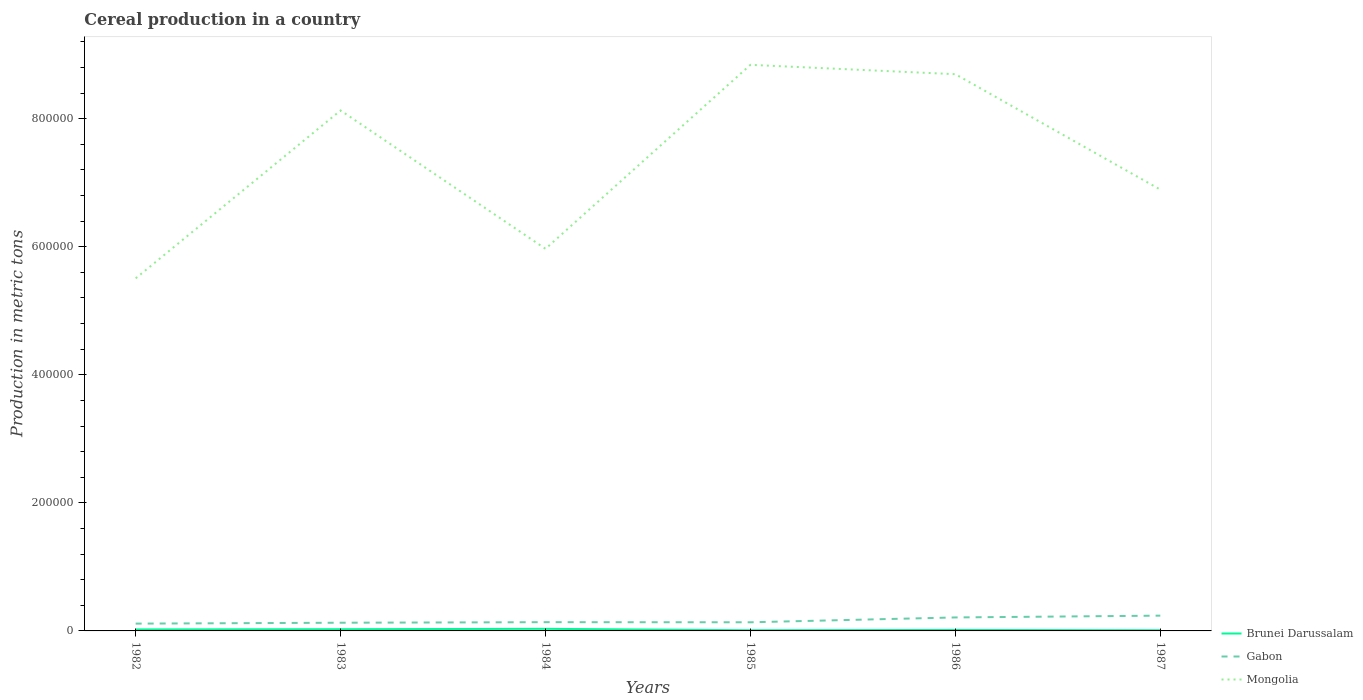How many different coloured lines are there?
Provide a short and direct response. 3. Across all years, what is the maximum total cereal production in Brunei Darussalam?
Offer a terse response. 1080. In which year was the total cereal production in Brunei Darussalam maximum?
Offer a very short reply. 1987. What is the total total cereal production in Brunei Darussalam in the graph?
Your response must be concise. -458. What is the difference between the highest and the second highest total cereal production in Gabon?
Offer a terse response. 1.25e+04. Is the total cereal production in Mongolia strictly greater than the total cereal production in Brunei Darussalam over the years?
Ensure brevity in your answer.  No. What is the difference between two consecutive major ticks on the Y-axis?
Give a very brief answer. 2.00e+05. Does the graph contain any zero values?
Provide a short and direct response. No. Where does the legend appear in the graph?
Ensure brevity in your answer.  Bottom right. What is the title of the graph?
Ensure brevity in your answer.  Cereal production in a country. Does "French Polynesia" appear as one of the legend labels in the graph?
Ensure brevity in your answer.  No. What is the label or title of the X-axis?
Keep it short and to the point. Years. What is the label or title of the Y-axis?
Your answer should be very brief. Production in metric tons. What is the Production in metric tons of Brunei Darussalam in 1982?
Offer a terse response. 2366. What is the Production in metric tons in Gabon in 1982?
Keep it short and to the point. 1.14e+04. What is the Production in metric tons in Mongolia in 1982?
Your answer should be very brief. 5.51e+05. What is the Production in metric tons in Brunei Darussalam in 1983?
Your response must be concise. 2676. What is the Production in metric tons in Gabon in 1983?
Your answer should be very brief. 1.28e+04. What is the Production in metric tons in Mongolia in 1983?
Your response must be concise. 8.13e+05. What is the Production in metric tons of Brunei Darussalam in 1984?
Provide a short and direct response. 3270. What is the Production in metric tons in Gabon in 1984?
Offer a terse response. 1.37e+04. What is the Production in metric tons in Mongolia in 1984?
Offer a very short reply. 5.97e+05. What is the Production in metric tons in Brunei Darussalam in 1985?
Provide a succinct answer. 1082. What is the Production in metric tons in Gabon in 1985?
Make the answer very short. 1.35e+04. What is the Production in metric tons of Mongolia in 1985?
Offer a very short reply. 8.84e+05. What is the Production in metric tons of Brunei Darussalam in 1986?
Ensure brevity in your answer.  1540. What is the Production in metric tons in Gabon in 1986?
Offer a terse response. 2.11e+04. What is the Production in metric tons in Mongolia in 1986?
Keep it short and to the point. 8.69e+05. What is the Production in metric tons of Brunei Darussalam in 1987?
Give a very brief answer. 1080. What is the Production in metric tons of Gabon in 1987?
Your answer should be very brief. 2.39e+04. What is the Production in metric tons in Mongolia in 1987?
Keep it short and to the point. 6.89e+05. Across all years, what is the maximum Production in metric tons of Brunei Darussalam?
Offer a terse response. 3270. Across all years, what is the maximum Production in metric tons of Gabon?
Your answer should be very brief. 2.39e+04. Across all years, what is the maximum Production in metric tons in Mongolia?
Provide a succinct answer. 8.84e+05. Across all years, what is the minimum Production in metric tons in Brunei Darussalam?
Your answer should be very brief. 1080. Across all years, what is the minimum Production in metric tons in Gabon?
Your answer should be compact. 1.14e+04. Across all years, what is the minimum Production in metric tons in Mongolia?
Provide a succinct answer. 5.51e+05. What is the total Production in metric tons in Brunei Darussalam in the graph?
Your answer should be very brief. 1.20e+04. What is the total Production in metric tons in Gabon in the graph?
Ensure brevity in your answer.  9.63e+04. What is the total Production in metric tons of Mongolia in the graph?
Provide a succinct answer. 4.40e+06. What is the difference between the Production in metric tons of Brunei Darussalam in 1982 and that in 1983?
Make the answer very short. -310. What is the difference between the Production in metric tons in Gabon in 1982 and that in 1983?
Keep it short and to the point. -1400. What is the difference between the Production in metric tons of Mongolia in 1982 and that in 1983?
Ensure brevity in your answer.  -2.62e+05. What is the difference between the Production in metric tons of Brunei Darussalam in 1982 and that in 1984?
Offer a terse response. -904. What is the difference between the Production in metric tons in Gabon in 1982 and that in 1984?
Offer a very short reply. -2262. What is the difference between the Production in metric tons of Mongolia in 1982 and that in 1984?
Provide a succinct answer. -4.61e+04. What is the difference between the Production in metric tons of Brunei Darussalam in 1982 and that in 1985?
Your answer should be very brief. 1284. What is the difference between the Production in metric tons of Gabon in 1982 and that in 1985?
Your answer should be very brief. -2100. What is the difference between the Production in metric tons of Mongolia in 1982 and that in 1985?
Make the answer very short. -3.33e+05. What is the difference between the Production in metric tons of Brunei Darussalam in 1982 and that in 1986?
Keep it short and to the point. 826. What is the difference between the Production in metric tons in Gabon in 1982 and that in 1986?
Offer a very short reply. -9660. What is the difference between the Production in metric tons of Mongolia in 1982 and that in 1986?
Make the answer very short. -3.19e+05. What is the difference between the Production in metric tons of Brunei Darussalam in 1982 and that in 1987?
Your response must be concise. 1286. What is the difference between the Production in metric tons of Gabon in 1982 and that in 1987?
Your answer should be compact. -1.25e+04. What is the difference between the Production in metric tons in Mongolia in 1982 and that in 1987?
Provide a succinct answer. -1.39e+05. What is the difference between the Production in metric tons of Brunei Darussalam in 1983 and that in 1984?
Keep it short and to the point. -594. What is the difference between the Production in metric tons of Gabon in 1983 and that in 1984?
Keep it short and to the point. -862. What is the difference between the Production in metric tons of Mongolia in 1983 and that in 1984?
Your response must be concise. 2.16e+05. What is the difference between the Production in metric tons of Brunei Darussalam in 1983 and that in 1985?
Your response must be concise. 1594. What is the difference between the Production in metric tons of Gabon in 1983 and that in 1985?
Your answer should be compact. -700. What is the difference between the Production in metric tons of Mongolia in 1983 and that in 1985?
Provide a short and direct response. -7.12e+04. What is the difference between the Production in metric tons in Brunei Darussalam in 1983 and that in 1986?
Offer a terse response. 1136. What is the difference between the Production in metric tons of Gabon in 1983 and that in 1986?
Provide a succinct answer. -8260. What is the difference between the Production in metric tons of Mongolia in 1983 and that in 1986?
Ensure brevity in your answer.  -5.66e+04. What is the difference between the Production in metric tons in Brunei Darussalam in 1983 and that in 1987?
Ensure brevity in your answer.  1596. What is the difference between the Production in metric tons in Gabon in 1983 and that in 1987?
Your response must be concise. -1.11e+04. What is the difference between the Production in metric tons of Mongolia in 1983 and that in 1987?
Offer a terse response. 1.24e+05. What is the difference between the Production in metric tons of Brunei Darussalam in 1984 and that in 1985?
Your answer should be very brief. 2188. What is the difference between the Production in metric tons in Gabon in 1984 and that in 1985?
Your answer should be very brief. 162. What is the difference between the Production in metric tons in Mongolia in 1984 and that in 1985?
Your answer should be compact. -2.87e+05. What is the difference between the Production in metric tons of Brunei Darussalam in 1984 and that in 1986?
Give a very brief answer. 1730. What is the difference between the Production in metric tons of Gabon in 1984 and that in 1986?
Ensure brevity in your answer.  -7398. What is the difference between the Production in metric tons in Mongolia in 1984 and that in 1986?
Give a very brief answer. -2.73e+05. What is the difference between the Production in metric tons in Brunei Darussalam in 1984 and that in 1987?
Make the answer very short. 2190. What is the difference between the Production in metric tons in Gabon in 1984 and that in 1987?
Make the answer very short. -1.02e+04. What is the difference between the Production in metric tons in Mongolia in 1984 and that in 1987?
Offer a very short reply. -9.25e+04. What is the difference between the Production in metric tons of Brunei Darussalam in 1985 and that in 1986?
Give a very brief answer. -458. What is the difference between the Production in metric tons of Gabon in 1985 and that in 1986?
Offer a very short reply. -7560. What is the difference between the Production in metric tons in Mongolia in 1985 and that in 1986?
Provide a succinct answer. 1.46e+04. What is the difference between the Production in metric tons of Brunei Darussalam in 1985 and that in 1987?
Give a very brief answer. 2. What is the difference between the Production in metric tons of Gabon in 1985 and that in 1987?
Your answer should be compact. -1.04e+04. What is the difference between the Production in metric tons of Mongolia in 1985 and that in 1987?
Provide a succinct answer. 1.95e+05. What is the difference between the Production in metric tons in Brunei Darussalam in 1986 and that in 1987?
Ensure brevity in your answer.  460. What is the difference between the Production in metric tons in Gabon in 1986 and that in 1987?
Offer a terse response. -2798. What is the difference between the Production in metric tons of Mongolia in 1986 and that in 1987?
Provide a short and direct response. 1.80e+05. What is the difference between the Production in metric tons in Brunei Darussalam in 1982 and the Production in metric tons in Gabon in 1983?
Keep it short and to the point. -1.04e+04. What is the difference between the Production in metric tons of Brunei Darussalam in 1982 and the Production in metric tons of Mongolia in 1983?
Offer a very short reply. -8.10e+05. What is the difference between the Production in metric tons in Gabon in 1982 and the Production in metric tons in Mongolia in 1983?
Give a very brief answer. -8.01e+05. What is the difference between the Production in metric tons of Brunei Darussalam in 1982 and the Production in metric tons of Gabon in 1984?
Keep it short and to the point. -1.13e+04. What is the difference between the Production in metric tons of Brunei Darussalam in 1982 and the Production in metric tons of Mongolia in 1984?
Offer a very short reply. -5.94e+05. What is the difference between the Production in metric tons in Gabon in 1982 and the Production in metric tons in Mongolia in 1984?
Ensure brevity in your answer.  -5.85e+05. What is the difference between the Production in metric tons of Brunei Darussalam in 1982 and the Production in metric tons of Gabon in 1985?
Give a very brief answer. -1.11e+04. What is the difference between the Production in metric tons in Brunei Darussalam in 1982 and the Production in metric tons in Mongolia in 1985?
Your answer should be very brief. -8.82e+05. What is the difference between the Production in metric tons of Gabon in 1982 and the Production in metric tons of Mongolia in 1985?
Provide a short and direct response. -8.73e+05. What is the difference between the Production in metric tons of Brunei Darussalam in 1982 and the Production in metric tons of Gabon in 1986?
Keep it short and to the point. -1.87e+04. What is the difference between the Production in metric tons in Brunei Darussalam in 1982 and the Production in metric tons in Mongolia in 1986?
Provide a short and direct response. -8.67e+05. What is the difference between the Production in metric tons of Gabon in 1982 and the Production in metric tons of Mongolia in 1986?
Your response must be concise. -8.58e+05. What is the difference between the Production in metric tons in Brunei Darussalam in 1982 and the Production in metric tons in Gabon in 1987?
Your answer should be compact. -2.15e+04. What is the difference between the Production in metric tons in Brunei Darussalam in 1982 and the Production in metric tons in Mongolia in 1987?
Provide a short and direct response. -6.87e+05. What is the difference between the Production in metric tons of Gabon in 1982 and the Production in metric tons of Mongolia in 1987?
Your answer should be compact. -6.78e+05. What is the difference between the Production in metric tons of Brunei Darussalam in 1983 and the Production in metric tons of Gabon in 1984?
Offer a terse response. -1.10e+04. What is the difference between the Production in metric tons of Brunei Darussalam in 1983 and the Production in metric tons of Mongolia in 1984?
Make the answer very short. -5.94e+05. What is the difference between the Production in metric tons in Gabon in 1983 and the Production in metric tons in Mongolia in 1984?
Your answer should be very brief. -5.84e+05. What is the difference between the Production in metric tons in Brunei Darussalam in 1983 and the Production in metric tons in Gabon in 1985?
Offer a very short reply. -1.08e+04. What is the difference between the Production in metric tons of Brunei Darussalam in 1983 and the Production in metric tons of Mongolia in 1985?
Keep it short and to the point. -8.81e+05. What is the difference between the Production in metric tons of Gabon in 1983 and the Production in metric tons of Mongolia in 1985?
Give a very brief answer. -8.71e+05. What is the difference between the Production in metric tons in Brunei Darussalam in 1983 and the Production in metric tons in Gabon in 1986?
Your answer should be compact. -1.84e+04. What is the difference between the Production in metric tons in Brunei Darussalam in 1983 and the Production in metric tons in Mongolia in 1986?
Provide a short and direct response. -8.67e+05. What is the difference between the Production in metric tons of Gabon in 1983 and the Production in metric tons of Mongolia in 1986?
Your answer should be very brief. -8.57e+05. What is the difference between the Production in metric tons in Brunei Darussalam in 1983 and the Production in metric tons in Gabon in 1987?
Provide a short and direct response. -2.12e+04. What is the difference between the Production in metric tons in Brunei Darussalam in 1983 and the Production in metric tons in Mongolia in 1987?
Give a very brief answer. -6.87e+05. What is the difference between the Production in metric tons of Gabon in 1983 and the Production in metric tons of Mongolia in 1987?
Offer a terse response. -6.76e+05. What is the difference between the Production in metric tons of Brunei Darussalam in 1984 and the Production in metric tons of Gabon in 1985?
Ensure brevity in your answer.  -1.02e+04. What is the difference between the Production in metric tons in Brunei Darussalam in 1984 and the Production in metric tons in Mongolia in 1985?
Your answer should be compact. -8.81e+05. What is the difference between the Production in metric tons of Gabon in 1984 and the Production in metric tons of Mongolia in 1985?
Ensure brevity in your answer.  -8.70e+05. What is the difference between the Production in metric tons of Brunei Darussalam in 1984 and the Production in metric tons of Gabon in 1986?
Ensure brevity in your answer.  -1.78e+04. What is the difference between the Production in metric tons of Brunei Darussalam in 1984 and the Production in metric tons of Mongolia in 1986?
Keep it short and to the point. -8.66e+05. What is the difference between the Production in metric tons of Gabon in 1984 and the Production in metric tons of Mongolia in 1986?
Your answer should be compact. -8.56e+05. What is the difference between the Production in metric tons of Brunei Darussalam in 1984 and the Production in metric tons of Gabon in 1987?
Provide a short and direct response. -2.06e+04. What is the difference between the Production in metric tons in Brunei Darussalam in 1984 and the Production in metric tons in Mongolia in 1987?
Offer a terse response. -6.86e+05. What is the difference between the Production in metric tons in Gabon in 1984 and the Production in metric tons in Mongolia in 1987?
Your answer should be very brief. -6.76e+05. What is the difference between the Production in metric tons of Brunei Darussalam in 1985 and the Production in metric tons of Gabon in 1986?
Your answer should be very brief. -2.00e+04. What is the difference between the Production in metric tons in Brunei Darussalam in 1985 and the Production in metric tons in Mongolia in 1986?
Make the answer very short. -8.68e+05. What is the difference between the Production in metric tons in Gabon in 1985 and the Production in metric tons in Mongolia in 1986?
Your answer should be compact. -8.56e+05. What is the difference between the Production in metric tons in Brunei Darussalam in 1985 and the Production in metric tons in Gabon in 1987?
Your answer should be very brief. -2.28e+04. What is the difference between the Production in metric tons in Brunei Darussalam in 1985 and the Production in metric tons in Mongolia in 1987?
Make the answer very short. -6.88e+05. What is the difference between the Production in metric tons in Gabon in 1985 and the Production in metric tons in Mongolia in 1987?
Your answer should be compact. -6.76e+05. What is the difference between the Production in metric tons in Brunei Darussalam in 1986 and the Production in metric tons in Gabon in 1987?
Give a very brief answer. -2.23e+04. What is the difference between the Production in metric tons in Brunei Darussalam in 1986 and the Production in metric tons in Mongolia in 1987?
Keep it short and to the point. -6.88e+05. What is the difference between the Production in metric tons of Gabon in 1986 and the Production in metric tons of Mongolia in 1987?
Provide a short and direct response. -6.68e+05. What is the average Production in metric tons of Brunei Darussalam per year?
Your answer should be compact. 2002.33. What is the average Production in metric tons of Gabon per year?
Provide a succinct answer. 1.60e+04. What is the average Production in metric tons of Mongolia per year?
Your response must be concise. 7.34e+05. In the year 1982, what is the difference between the Production in metric tons in Brunei Darussalam and Production in metric tons in Gabon?
Your answer should be very brief. -9034. In the year 1982, what is the difference between the Production in metric tons in Brunei Darussalam and Production in metric tons in Mongolia?
Keep it short and to the point. -5.48e+05. In the year 1982, what is the difference between the Production in metric tons of Gabon and Production in metric tons of Mongolia?
Your response must be concise. -5.39e+05. In the year 1983, what is the difference between the Production in metric tons of Brunei Darussalam and Production in metric tons of Gabon?
Provide a short and direct response. -1.01e+04. In the year 1983, what is the difference between the Production in metric tons of Brunei Darussalam and Production in metric tons of Mongolia?
Provide a short and direct response. -8.10e+05. In the year 1983, what is the difference between the Production in metric tons in Gabon and Production in metric tons in Mongolia?
Your response must be concise. -8.00e+05. In the year 1984, what is the difference between the Production in metric tons of Brunei Darussalam and Production in metric tons of Gabon?
Your answer should be very brief. -1.04e+04. In the year 1984, what is the difference between the Production in metric tons in Brunei Darussalam and Production in metric tons in Mongolia?
Provide a succinct answer. -5.93e+05. In the year 1984, what is the difference between the Production in metric tons in Gabon and Production in metric tons in Mongolia?
Your answer should be very brief. -5.83e+05. In the year 1985, what is the difference between the Production in metric tons of Brunei Darussalam and Production in metric tons of Gabon?
Keep it short and to the point. -1.24e+04. In the year 1985, what is the difference between the Production in metric tons of Brunei Darussalam and Production in metric tons of Mongolia?
Your answer should be very brief. -8.83e+05. In the year 1985, what is the difference between the Production in metric tons of Gabon and Production in metric tons of Mongolia?
Your response must be concise. -8.70e+05. In the year 1986, what is the difference between the Production in metric tons of Brunei Darussalam and Production in metric tons of Gabon?
Make the answer very short. -1.95e+04. In the year 1986, what is the difference between the Production in metric tons in Brunei Darussalam and Production in metric tons in Mongolia?
Make the answer very short. -8.68e+05. In the year 1986, what is the difference between the Production in metric tons of Gabon and Production in metric tons of Mongolia?
Your response must be concise. -8.48e+05. In the year 1987, what is the difference between the Production in metric tons in Brunei Darussalam and Production in metric tons in Gabon?
Give a very brief answer. -2.28e+04. In the year 1987, what is the difference between the Production in metric tons of Brunei Darussalam and Production in metric tons of Mongolia?
Offer a very short reply. -6.88e+05. In the year 1987, what is the difference between the Production in metric tons in Gabon and Production in metric tons in Mongolia?
Your answer should be compact. -6.65e+05. What is the ratio of the Production in metric tons of Brunei Darussalam in 1982 to that in 1983?
Your answer should be very brief. 0.88. What is the ratio of the Production in metric tons in Gabon in 1982 to that in 1983?
Keep it short and to the point. 0.89. What is the ratio of the Production in metric tons of Mongolia in 1982 to that in 1983?
Offer a terse response. 0.68. What is the ratio of the Production in metric tons of Brunei Darussalam in 1982 to that in 1984?
Your answer should be compact. 0.72. What is the ratio of the Production in metric tons in Gabon in 1982 to that in 1984?
Keep it short and to the point. 0.83. What is the ratio of the Production in metric tons in Mongolia in 1982 to that in 1984?
Your response must be concise. 0.92. What is the ratio of the Production in metric tons in Brunei Darussalam in 1982 to that in 1985?
Provide a succinct answer. 2.19. What is the ratio of the Production in metric tons of Gabon in 1982 to that in 1985?
Provide a short and direct response. 0.84. What is the ratio of the Production in metric tons in Mongolia in 1982 to that in 1985?
Keep it short and to the point. 0.62. What is the ratio of the Production in metric tons in Brunei Darussalam in 1982 to that in 1986?
Make the answer very short. 1.54. What is the ratio of the Production in metric tons of Gabon in 1982 to that in 1986?
Provide a short and direct response. 0.54. What is the ratio of the Production in metric tons in Mongolia in 1982 to that in 1986?
Give a very brief answer. 0.63. What is the ratio of the Production in metric tons in Brunei Darussalam in 1982 to that in 1987?
Your response must be concise. 2.19. What is the ratio of the Production in metric tons in Gabon in 1982 to that in 1987?
Your answer should be very brief. 0.48. What is the ratio of the Production in metric tons in Mongolia in 1982 to that in 1987?
Offer a very short reply. 0.8. What is the ratio of the Production in metric tons in Brunei Darussalam in 1983 to that in 1984?
Your answer should be very brief. 0.82. What is the ratio of the Production in metric tons in Gabon in 1983 to that in 1984?
Your answer should be compact. 0.94. What is the ratio of the Production in metric tons in Mongolia in 1983 to that in 1984?
Offer a terse response. 1.36. What is the ratio of the Production in metric tons of Brunei Darussalam in 1983 to that in 1985?
Keep it short and to the point. 2.47. What is the ratio of the Production in metric tons in Gabon in 1983 to that in 1985?
Ensure brevity in your answer.  0.95. What is the ratio of the Production in metric tons in Mongolia in 1983 to that in 1985?
Your answer should be compact. 0.92. What is the ratio of the Production in metric tons of Brunei Darussalam in 1983 to that in 1986?
Your answer should be compact. 1.74. What is the ratio of the Production in metric tons in Gabon in 1983 to that in 1986?
Your response must be concise. 0.61. What is the ratio of the Production in metric tons in Mongolia in 1983 to that in 1986?
Provide a succinct answer. 0.93. What is the ratio of the Production in metric tons in Brunei Darussalam in 1983 to that in 1987?
Your answer should be compact. 2.48. What is the ratio of the Production in metric tons in Gabon in 1983 to that in 1987?
Keep it short and to the point. 0.54. What is the ratio of the Production in metric tons of Mongolia in 1983 to that in 1987?
Your response must be concise. 1.18. What is the ratio of the Production in metric tons in Brunei Darussalam in 1984 to that in 1985?
Provide a short and direct response. 3.02. What is the ratio of the Production in metric tons of Mongolia in 1984 to that in 1985?
Give a very brief answer. 0.68. What is the ratio of the Production in metric tons in Brunei Darussalam in 1984 to that in 1986?
Make the answer very short. 2.12. What is the ratio of the Production in metric tons in Gabon in 1984 to that in 1986?
Offer a terse response. 0.65. What is the ratio of the Production in metric tons in Mongolia in 1984 to that in 1986?
Keep it short and to the point. 0.69. What is the ratio of the Production in metric tons of Brunei Darussalam in 1984 to that in 1987?
Your response must be concise. 3.03. What is the ratio of the Production in metric tons of Gabon in 1984 to that in 1987?
Your answer should be compact. 0.57. What is the ratio of the Production in metric tons in Mongolia in 1984 to that in 1987?
Your answer should be very brief. 0.87. What is the ratio of the Production in metric tons of Brunei Darussalam in 1985 to that in 1986?
Offer a very short reply. 0.7. What is the ratio of the Production in metric tons of Gabon in 1985 to that in 1986?
Make the answer very short. 0.64. What is the ratio of the Production in metric tons of Mongolia in 1985 to that in 1986?
Offer a terse response. 1.02. What is the ratio of the Production in metric tons in Brunei Darussalam in 1985 to that in 1987?
Your response must be concise. 1. What is the ratio of the Production in metric tons of Gabon in 1985 to that in 1987?
Your response must be concise. 0.57. What is the ratio of the Production in metric tons in Mongolia in 1985 to that in 1987?
Offer a very short reply. 1.28. What is the ratio of the Production in metric tons of Brunei Darussalam in 1986 to that in 1987?
Give a very brief answer. 1.43. What is the ratio of the Production in metric tons in Gabon in 1986 to that in 1987?
Make the answer very short. 0.88. What is the ratio of the Production in metric tons in Mongolia in 1986 to that in 1987?
Provide a short and direct response. 1.26. What is the difference between the highest and the second highest Production in metric tons of Brunei Darussalam?
Make the answer very short. 594. What is the difference between the highest and the second highest Production in metric tons in Gabon?
Offer a very short reply. 2798. What is the difference between the highest and the second highest Production in metric tons in Mongolia?
Give a very brief answer. 1.46e+04. What is the difference between the highest and the lowest Production in metric tons in Brunei Darussalam?
Keep it short and to the point. 2190. What is the difference between the highest and the lowest Production in metric tons in Gabon?
Your response must be concise. 1.25e+04. What is the difference between the highest and the lowest Production in metric tons of Mongolia?
Provide a short and direct response. 3.33e+05. 